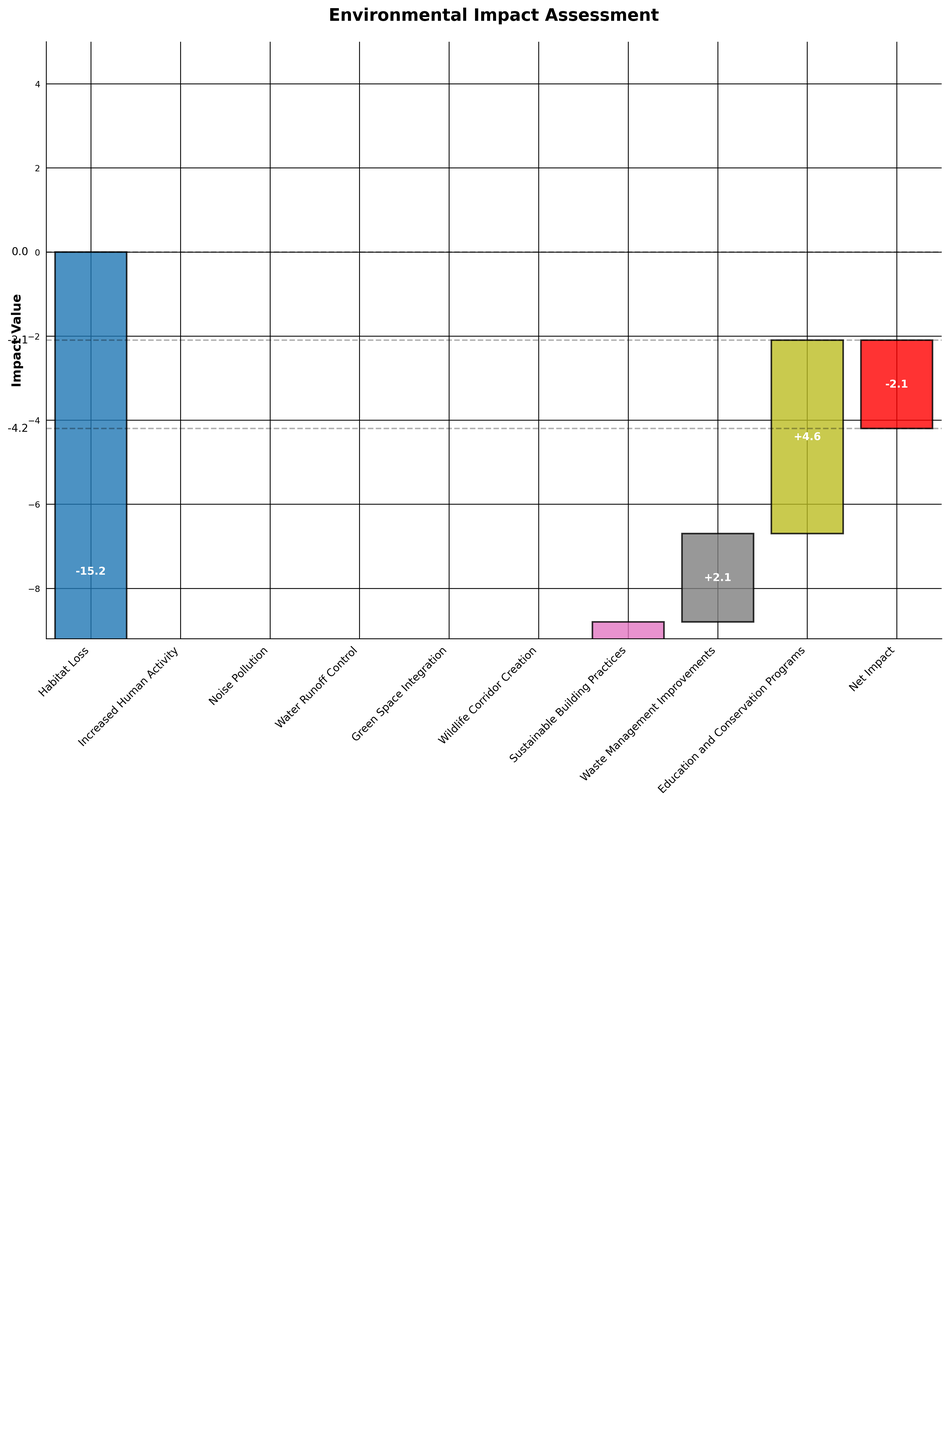What is the title of the chart? The title of the chart is prominently displayed at the top and labelled "Environmental Impact Assessment."
Answer: Environmental Impact Assessment How many categories are shown in the chart? The number of categories is determined by counting the labels on the x-axis. Each label represents one category. There are 10 categories.
Answer: 10 What is the value associated with habitat loss? The bar for habitat loss is coloured, and the value inside that bar is visible as -15.2.
Answer: -15.2 Which category has the highest positive impact on the ecosystem? By visually comparing the heights of the bars with positive values, the tallest bar among those is "Green Space Integration" with a value of 7.2.
Answer: Green Space Integration What is the net impact on the ecosystem after all changes? The net impact is denoted by the last bar in red and labelled with the final value on the chart. The value shown is -2.1.
Answer: -2.1 What is the cumulative impact before accounting for the net impact? Starting from the initial balanced value of 0, summing all the impacts (positive and negative) shown in between results: -15.2 - 8.7 - 6.3 + 4.5 + 7.2 + 5.8 + 3.9 + 2.1 + 4.6. The cumulative impact is -2.1 + 2.1 = 0. Adding the value of -2.1 leads us back to -2.1
Answer: -2.1 What is the overall impact of sustainable development efforts (wildlife corridor creation, sustainable building practices, waste management improvements, and education and conservation programs)? Sum the impacts from these categories: Wildlife Corridor Creation (5.8) + Sustainable Building Practices (3.9) + Waste Management Improvements (2.1) + Education and Conservation Programs (4.6). So, 5.8+ 3.9+ 2.1+4.6= 16.4
Answer: 16.4 Did any single category compensate for the total negative impact by itself? To find out if any single category with a positive impact counteracted the total negative impact (-15.2 - 8.7 - 6.3 = -30.2), we need to check if any positive value equals 30.2. No single positive value reaches this amount.
Answer: No Is the overall ecosystem balance currently positive or negative? The final net impact, shown as -2.1, indicates the overall balance remains slightly negative.
Answer: Negative 